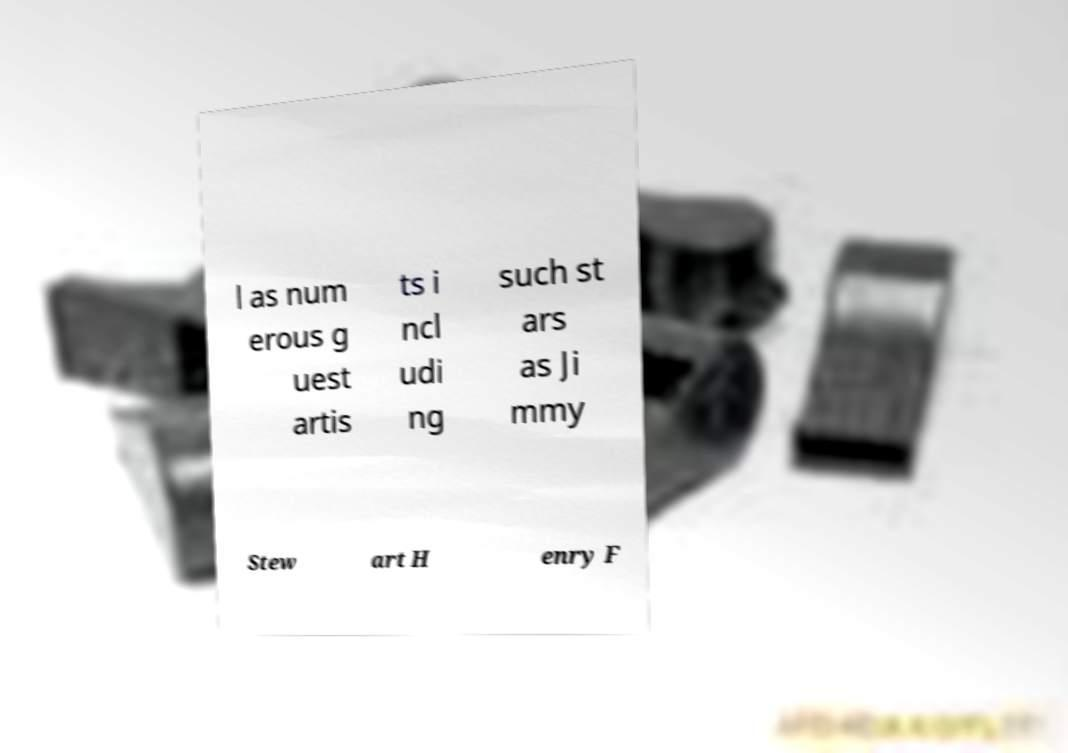Please identify and transcribe the text found in this image. l as num erous g uest artis ts i ncl udi ng such st ars as Ji mmy Stew art H enry F 